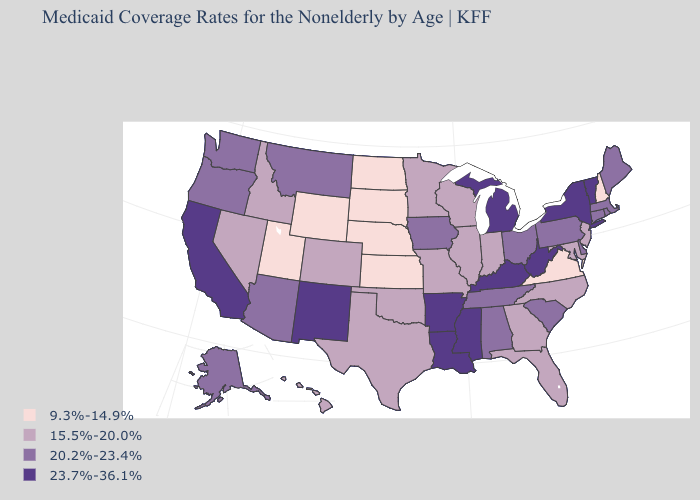What is the lowest value in the West?
Quick response, please. 9.3%-14.9%. Name the states that have a value in the range 20.2%-23.4%?
Answer briefly. Alabama, Alaska, Arizona, Connecticut, Delaware, Iowa, Maine, Massachusetts, Montana, Ohio, Oregon, Pennsylvania, Rhode Island, South Carolina, Tennessee, Washington. Which states hav the highest value in the MidWest?
Write a very short answer. Michigan. Name the states that have a value in the range 9.3%-14.9%?
Short answer required. Kansas, Nebraska, New Hampshire, North Dakota, South Dakota, Utah, Virginia, Wyoming. What is the value of Wyoming?
Give a very brief answer. 9.3%-14.9%. Name the states that have a value in the range 23.7%-36.1%?
Keep it brief. Arkansas, California, Kentucky, Louisiana, Michigan, Mississippi, New Mexico, New York, Vermont, West Virginia. Does Michigan have the highest value in the MidWest?
Answer briefly. Yes. Which states have the lowest value in the USA?
Answer briefly. Kansas, Nebraska, New Hampshire, North Dakota, South Dakota, Utah, Virginia, Wyoming. Does Idaho have a lower value than Washington?
Concise answer only. Yes. What is the highest value in the MidWest ?
Give a very brief answer. 23.7%-36.1%. Does New York have the highest value in the Northeast?
Concise answer only. Yes. Does Virginia have a higher value than Idaho?
Quick response, please. No. Does Ohio have the lowest value in the USA?
Keep it brief. No. 